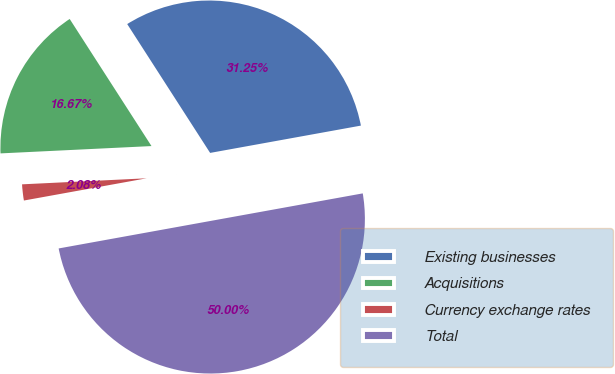<chart> <loc_0><loc_0><loc_500><loc_500><pie_chart><fcel>Existing businesses<fcel>Acquisitions<fcel>Currency exchange rates<fcel>Total<nl><fcel>31.25%<fcel>16.67%<fcel>2.08%<fcel>50.0%<nl></chart> 